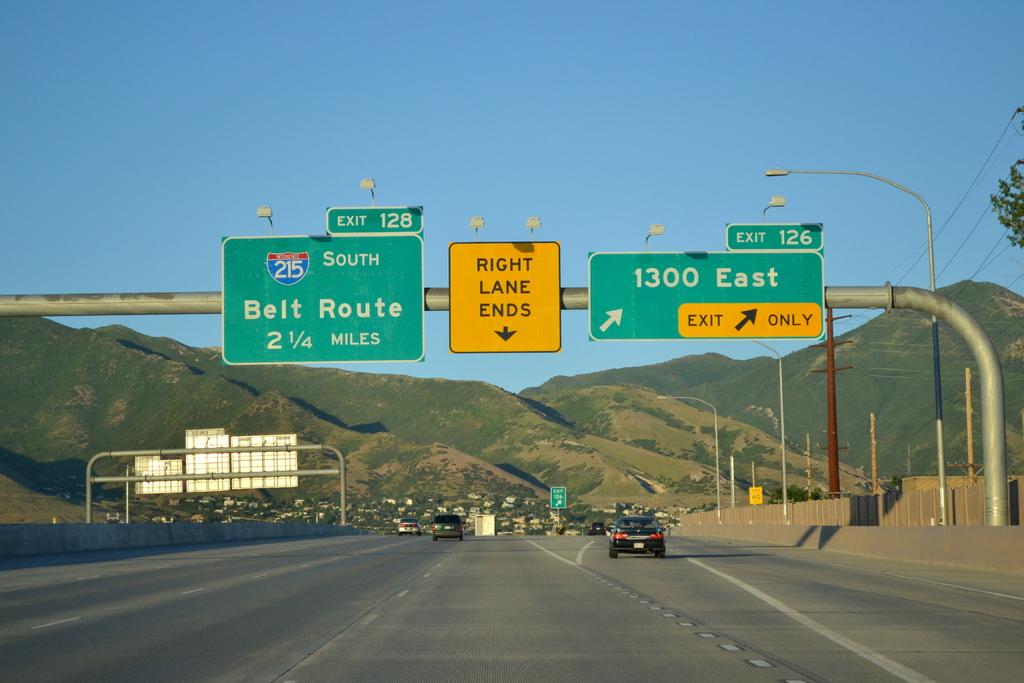How far to belt route?
Keep it short and to the point. 2 1/4 miles. 